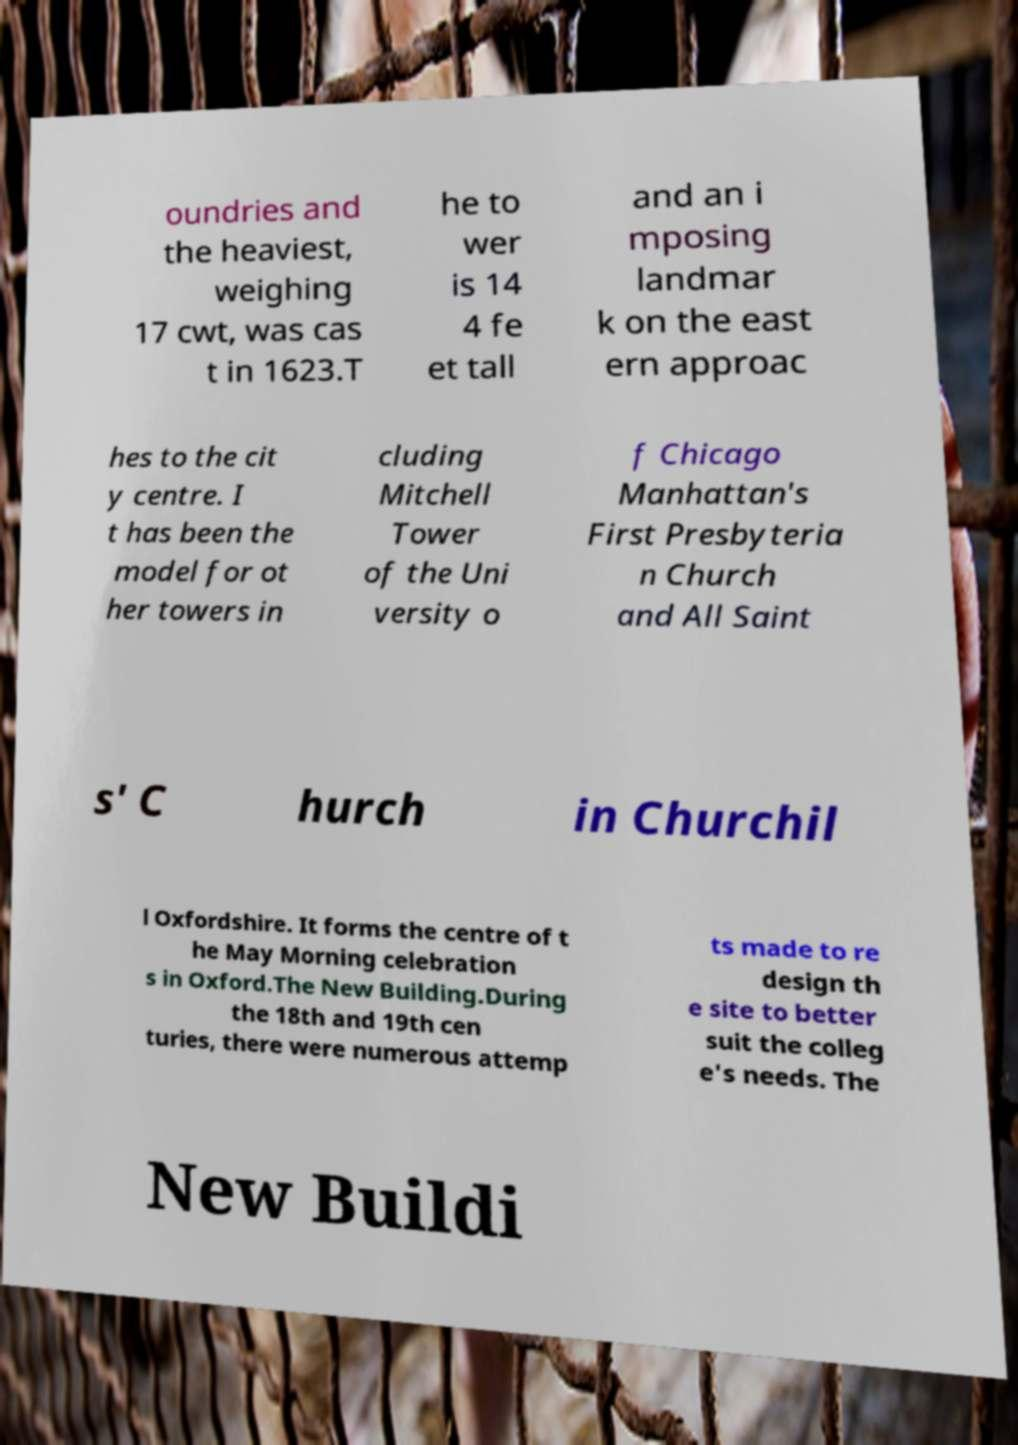I need the written content from this picture converted into text. Can you do that? oundries and the heaviest, weighing 17 cwt, was cas t in 1623.T he to wer is 14 4 fe et tall and an i mposing landmar k on the east ern approac hes to the cit y centre. I t has been the model for ot her towers in cluding Mitchell Tower of the Uni versity o f Chicago Manhattan's First Presbyteria n Church and All Saint s' C hurch in Churchil l Oxfordshire. It forms the centre of t he May Morning celebration s in Oxford.The New Building.During the 18th and 19th cen turies, there were numerous attemp ts made to re design th e site to better suit the colleg e's needs. The New Buildi 